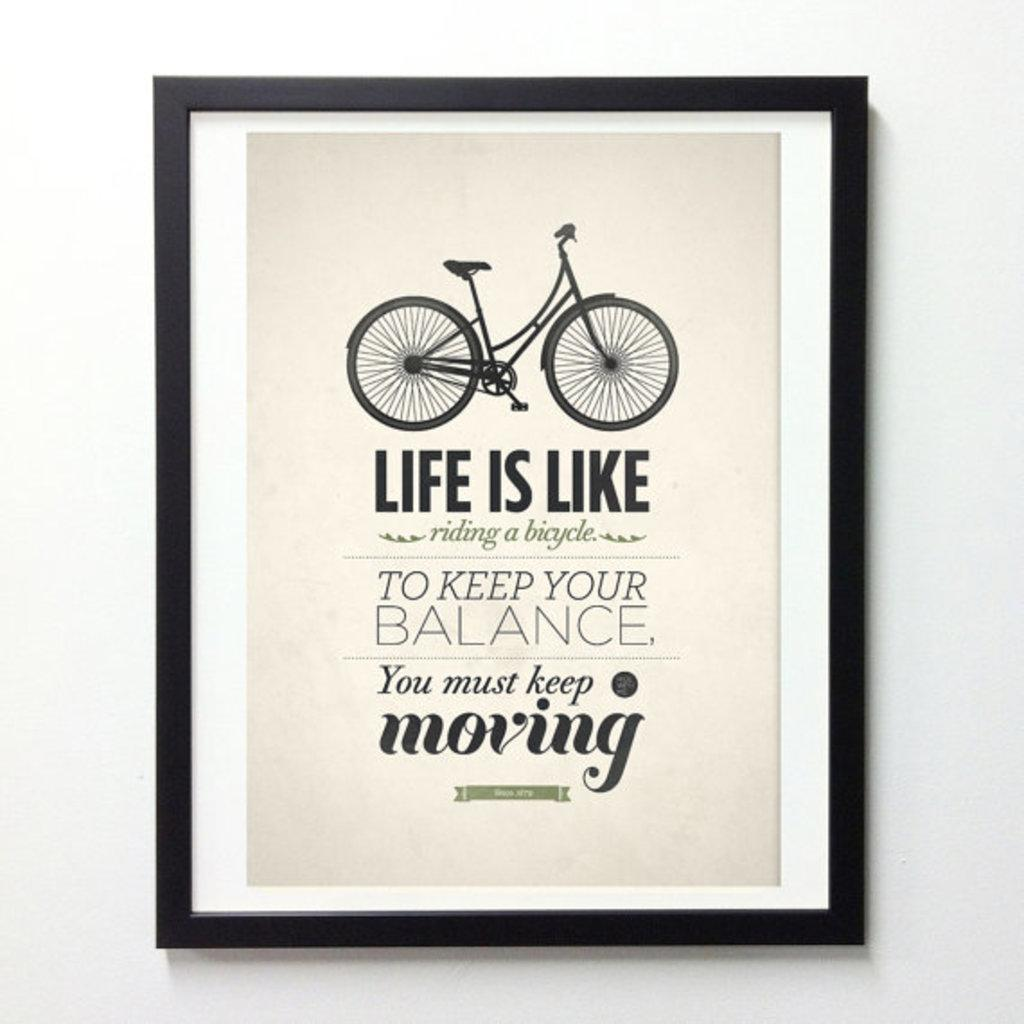What is hanging on the wall in the image? There is a photo on the wall in the image. What is depicted in the photo? The photo contains a picture of a bicycle. Are there any words or letters on the photo? Yes, there is text on the photo. What type of garden can be seen in the background of the photo? There is no garden visible in the image, as the photo only contains a picture of a bicycle. What color is the cap worn by the bicycle in the photo? There is no cap present on the bicycle in the photo, as it is a still image of a bicycle without any additional accessories. 